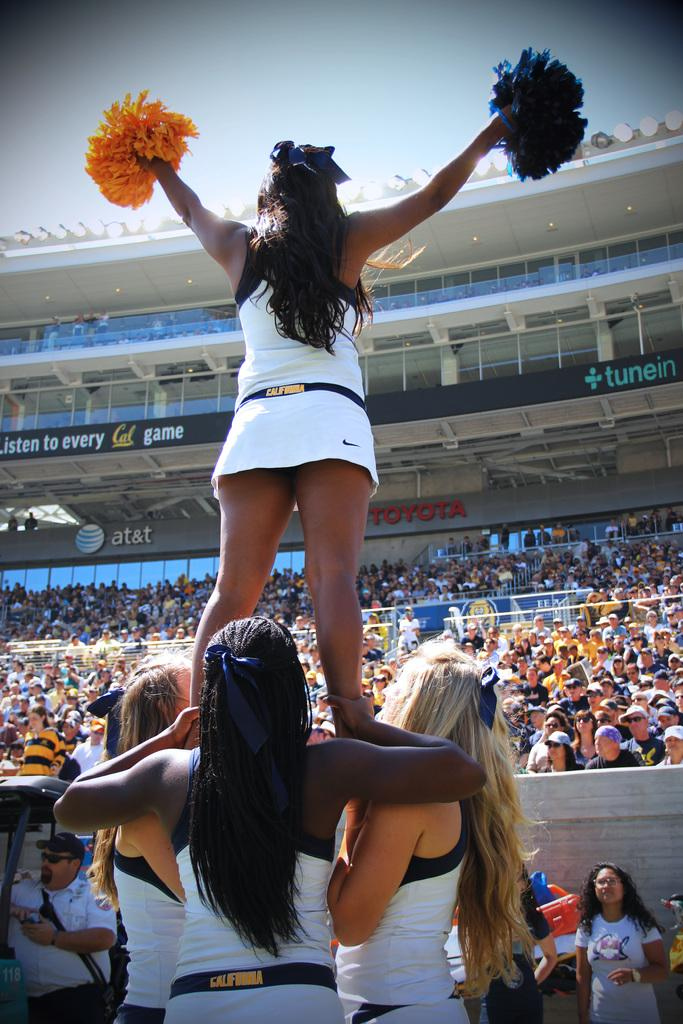How many people are in the image? There is a group of people in the image. Can you describe the woman in the middle of the image? The woman in the middle of the image is holding poms. What can be seen in the background of the image? There are hoardings and lights in the background of the image. What type of box is being used to perform tricks in the image? There is no box or any tricks being performed in the image; it features a group of people with a woman holding poms. Can you see any blades or skates in the image? There are no blades or skates present in the image. 